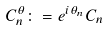<formula> <loc_0><loc_0><loc_500><loc_500>C _ { n } ^ { \theta } \colon = e ^ { i \theta _ { n } } C _ { n }</formula> 